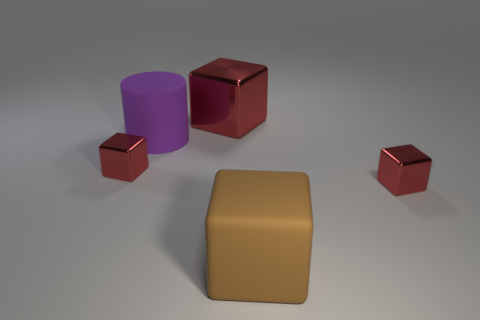Subtract all blue cylinders. How many red cubes are left? 3 Add 2 big red cubes. How many objects exist? 7 Subtract all cylinders. How many objects are left? 4 Add 4 matte objects. How many matte objects exist? 6 Subtract 0 green cubes. How many objects are left? 5 Subtract all big purple things. Subtract all big gray cylinders. How many objects are left? 4 Add 1 big red shiny blocks. How many big red shiny blocks are left? 2 